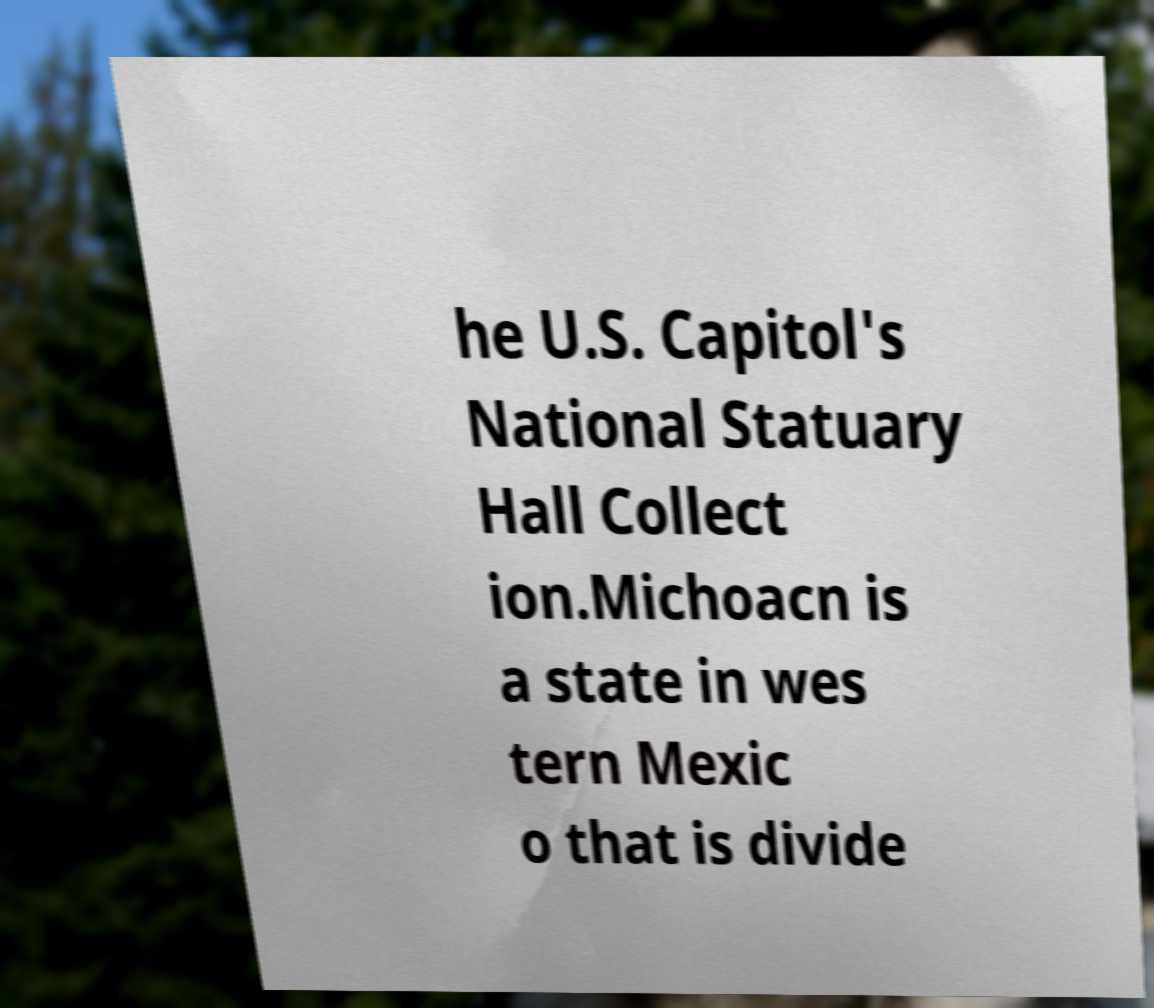What messages or text are displayed in this image? I need them in a readable, typed format. he U.S. Capitol's National Statuary Hall Collect ion.Michoacn is a state in wes tern Mexic o that is divide 